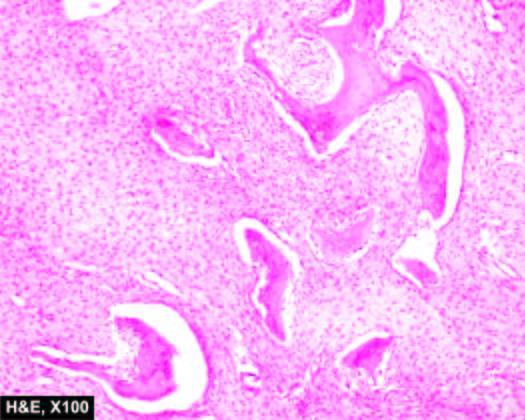do the wall of the stomach in the region of pyloric canal have fish-hook appearance surrounded by fibrous tissue?
Answer the question using a single word or phrase. No 